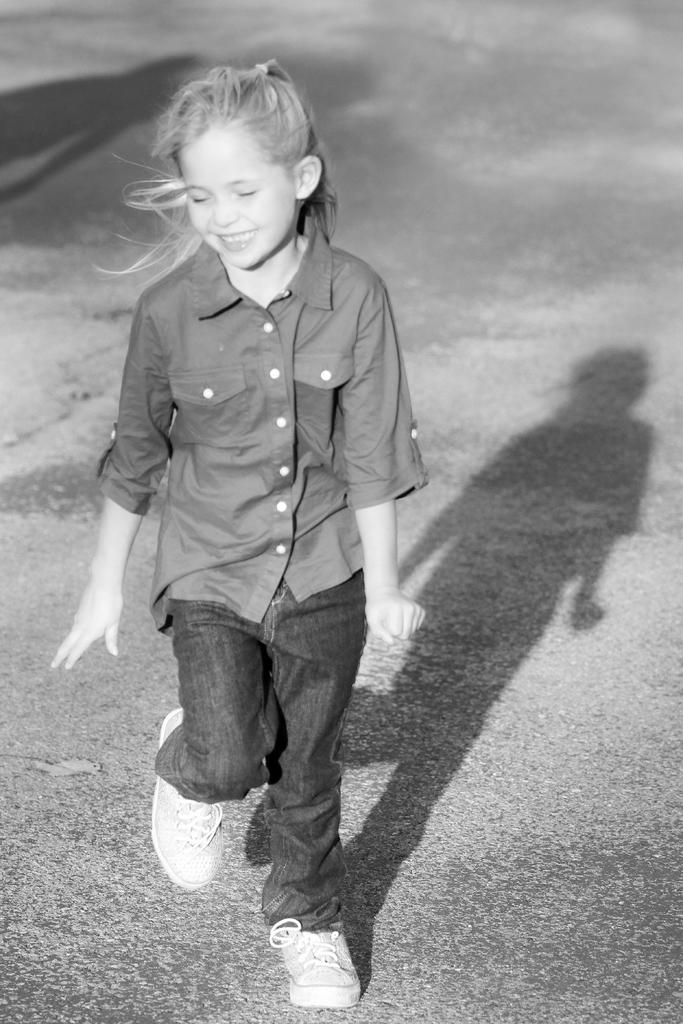Who is present in the image? There is a girl in the image. What is the girl doing in the image? The girl is standing in the image. What is the girl's facial expression in the image? The girl is smiling in the image. What can be seen on the ground in the image? The girl's shadow is visible on the road in the image. What is the color scheme of the image? The image is black and white. What type of mountain can be seen in the background of the image? There is no mountain present in the image; it is a black and white image of a girl standing on a road. 